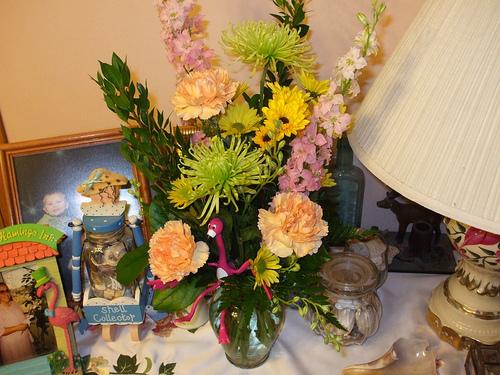Are there red flowers?
Give a very brief answer. No. Do you see a white lamp shade?
Give a very brief answer. Yes. Is the vase with the pink flowers shiny?
Be succinct. No. Are the people who own this house most likely rich or middle class?
Keep it brief. Middle class. What is the animal with the green hat?
Short answer required. Flamingo. 